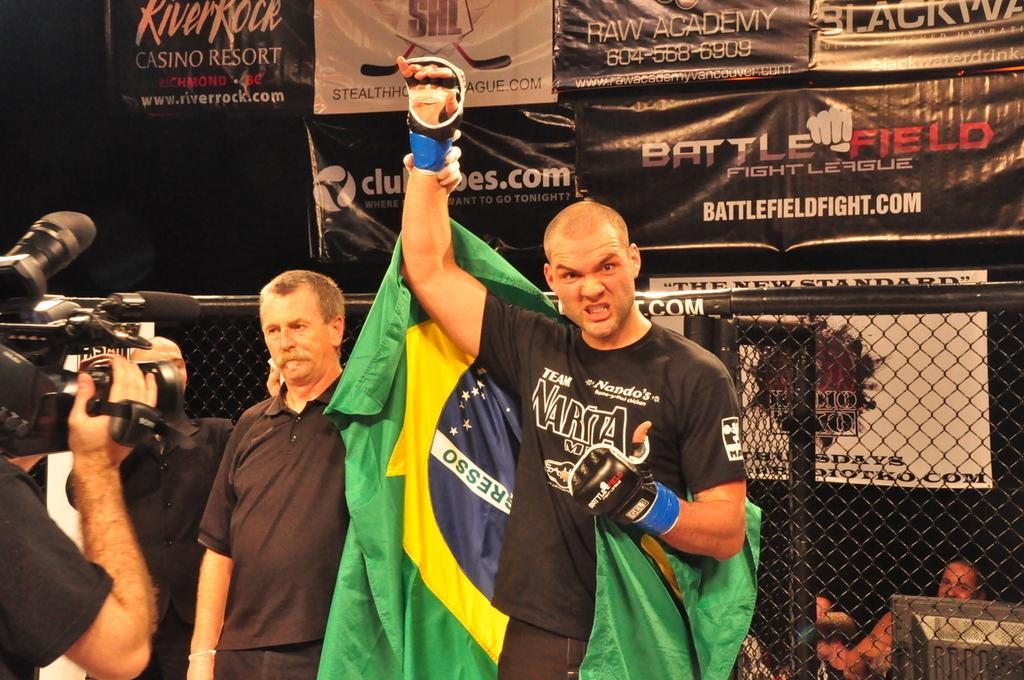<image>
Provide a brief description of the given image. a man wearing a NARITA shirt raises his hand with another man in front of a tv camera 